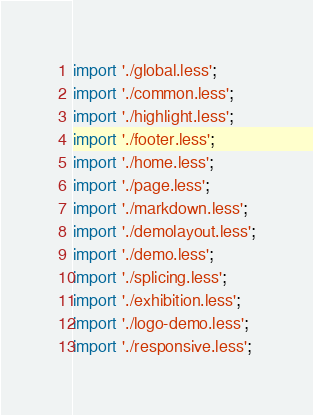Convert code to text. <code><loc_0><loc_0><loc_500><loc_500><_JavaScript_>import './global.less';
import './common.less';
import './highlight.less';
import './footer.less';
import './home.less';
import './page.less';
import './markdown.less';
import './demolayout.less';
import './demo.less';
import './splicing.less';
import './exhibition.less';
import './logo-demo.less';
import './responsive.less';
</code> 